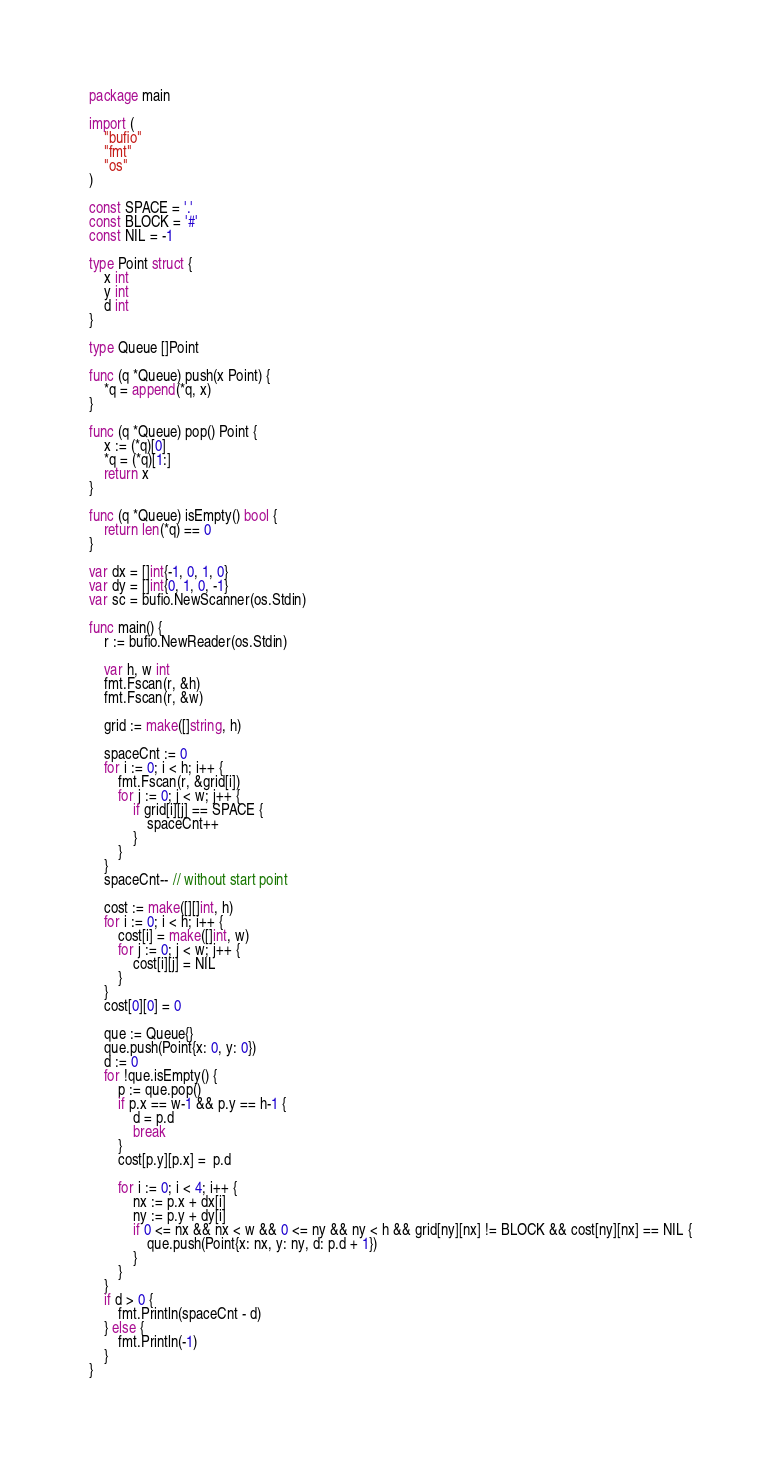<code> <loc_0><loc_0><loc_500><loc_500><_Go_>package main

import (
	"bufio"
	"fmt"
	"os"
)

const SPACE = '.'
const BLOCK = '#'
const NIL = -1

type Point struct {
	x int
	y int
	d int
}

type Queue []Point

func (q *Queue) push(x Point) {
	*q = append(*q, x)
}

func (q *Queue) pop() Point {
	x := (*q)[0]
	*q = (*q)[1:]
	return x
}

func (q *Queue) isEmpty() bool {
	return len(*q) == 0
}

var dx = []int{-1, 0, 1, 0}
var dy = []int{0, 1, 0, -1}
var sc = bufio.NewScanner(os.Stdin)

func main() {
	r := bufio.NewReader(os.Stdin)

	var h, w int
	fmt.Fscan(r, &h)
	fmt.Fscan(r, &w)

	grid := make([]string, h)

	spaceCnt := 0
	for i := 0; i < h; i++ {
		fmt.Fscan(r, &grid[i])
		for j := 0; j < w; j++ {
			if grid[i][j] == SPACE {
				spaceCnt++
			}
		}
	}
	spaceCnt-- // without start point

	cost := make([][]int, h)
	for i := 0; i < h; i++ {
		cost[i] = make([]int, w)
		for j := 0; j < w; j++ {
			cost[i][j] = NIL
		}
	}
	cost[0][0] = 0

	que := Queue{}
	que.push(Point{x: 0, y: 0})
	d := 0
	for !que.isEmpty() {
		p := que.pop()
		if p.x == w-1 && p.y == h-1 {
			d = p.d
			break
		}
		cost[p.y][p.x] =  p.d

		for i := 0; i < 4; i++ {
			nx := p.x + dx[i]
			ny := p.y + dy[i]
			if 0 <= nx && nx < w && 0 <= ny && ny < h && grid[ny][nx] != BLOCK && cost[ny][nx] == NIL {
				que.push(Point{x: nx, y: ny, d: p.d + 1})
			}
		}
	}
	if d > 0 {
		fmt.Println(spaceCnt - d)
	} else {
		fmt.Println(-1)
	}
}
</code> 